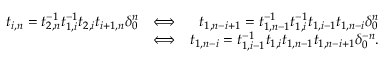<formula> <loc_0><loc_0><loc_500><loc_500>\begin{array} { r l r } { t _ { i , n } = t _ { 2 , n } ^ { - 1 } t _ { 1 , i } ^ { - 1 } t _ { 2 , i } t _ { i + 1 , n } \delta _ { 0 } ^ { n } } & { \Longleftrightarrow } & { t _ { 1 , n - i + 1 } = t _ { 1 , n - 1 } ^ { - 1 } t _ { 1 , i } ^ { - 1 } t _ { 1 , i - 1 } t _ { 1 , n - i } \delta _ { 0 } ^ { n } } \\ & { \Longleftrightarrow } & { t _ { 1 , n - i } = t _ { 1 , i - 1 } ^ { - 1 } t _ { 1 , i } t _ { 1 , n - 1 } t _ { 1 , n - i + 1 } \delta _ { 0 } ^ { - n } . } \end{array}</formula> 